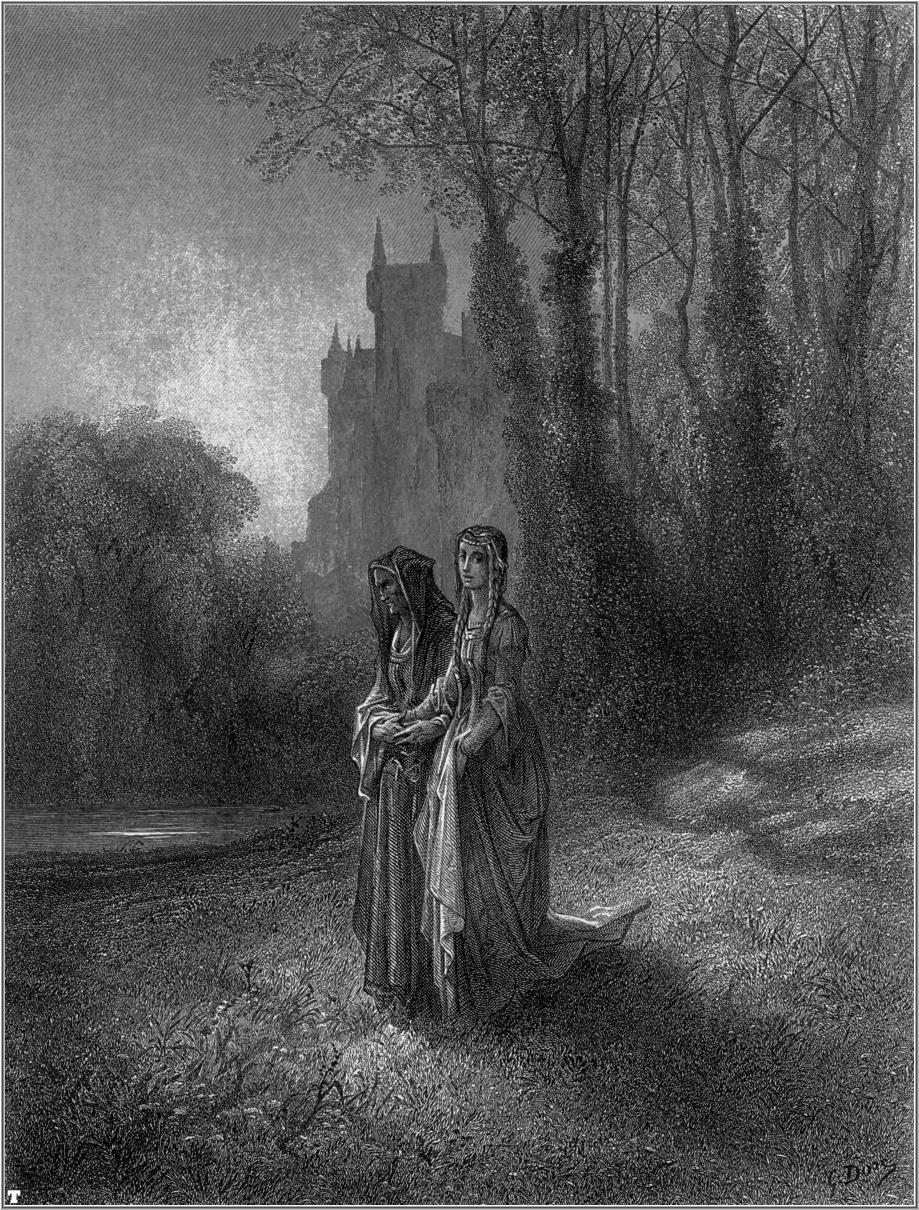If the castle were inhabited by a mystical creature, what would it be and why? The castle in the illustration would be inhabited by a wise and ancient dragon. This dragon is not a creature of destruction, but rather a guardian of the forest and the secrets it holds. Over centuries, it has amassed knowledge and treasures, and it watches over the land, ensuring balance and peace. The villagers respect and revere the dragon, offering it gifts and seeking its counsel in times of need. The dragon's presence adds an air of mystique and ancient power to the castle and surrounding forest, enhancing the illustration's rich narrative. 